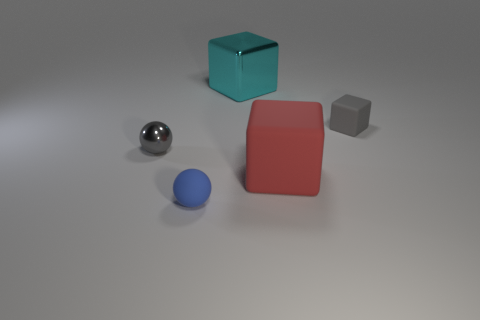Add 4 big spheres. How many objects exist? 9 Subtract all rubber blocks. How many blocks are left? 1 Subtract all large brown matte objects. Subtract all gray rubber blocks. How many objects are left? 4 Add 4 cyan things. How many cyan things are left? 5 Add 1 big cyan blocks. How many big cyan blocks exist? 2 Subtract all gray balls. How many balls are left? 1 Subtract 0 green cylinders. How many objects are left? 5 Subtract all spheres. How many objects are left? 3 Subtract all purple blocks. Subtract all blue spheres. How many blocks are left? 3 Subtract all purple spheres. How many gray cubes are left? 1 